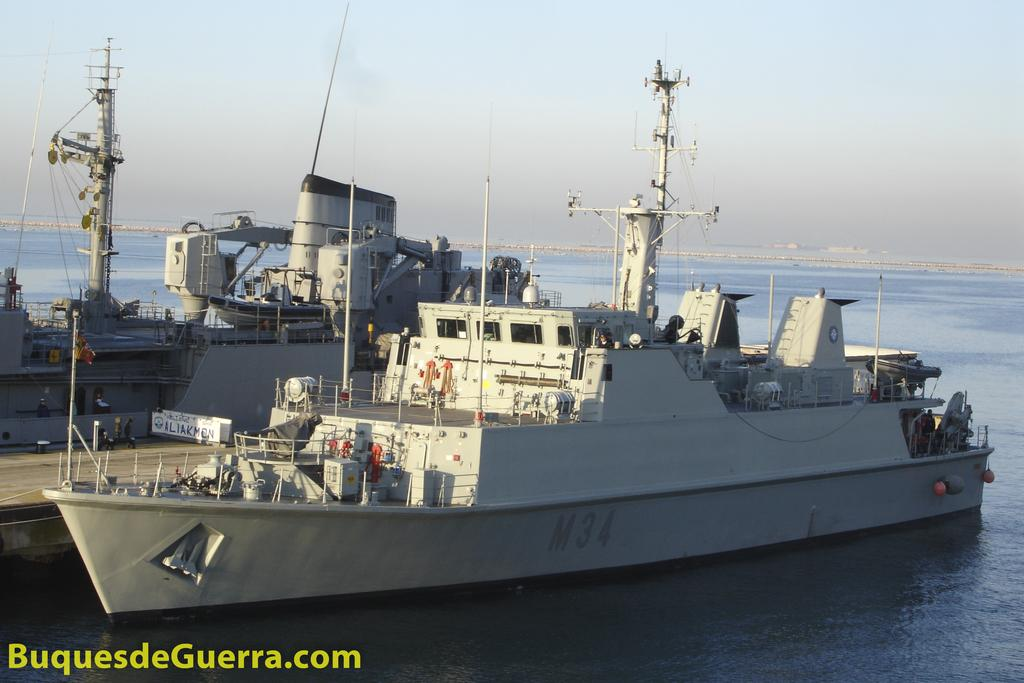What is the main subject of the image? The main subject of the image is ships. Where are the ships located? The ships are on the water. What can be seen in the background of the image? There is sky visible in the background of the image. Is there any text or marking at the bottom of the image? Yes, there is a watermark at the bottom of the image. What type of trail can be seen behind the ships in the image? There is no trail visible behind the ships in the image. Is there any indication of death or loss in the image? There is no indication of death or loss in the image; it features ships on the water. What kind of ornament is hanging from the mast of the ship? There is no ornament hanging from the mast of the ship in the image. 